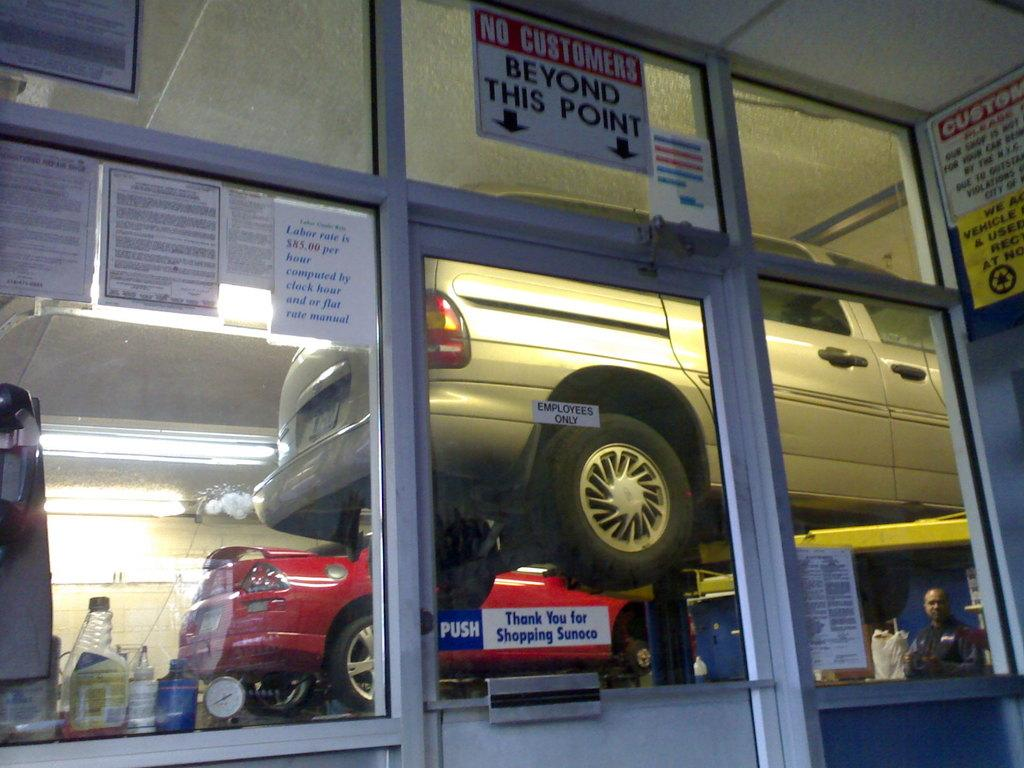What is displayed on the glass doors in the image? There are posters on the glass doors in the image. What can be seen through the glass doors? Vehicles, a person, a clock, bottles, and lights are visible through the glass doors. What is the background of the image? There is a wall in the background of the image. What type of metal is being burned in the image? There is no metal being burned in the image. What is the sun's position in the image? The sun is not visible in the image; only the sky is visible through the glass doors. 